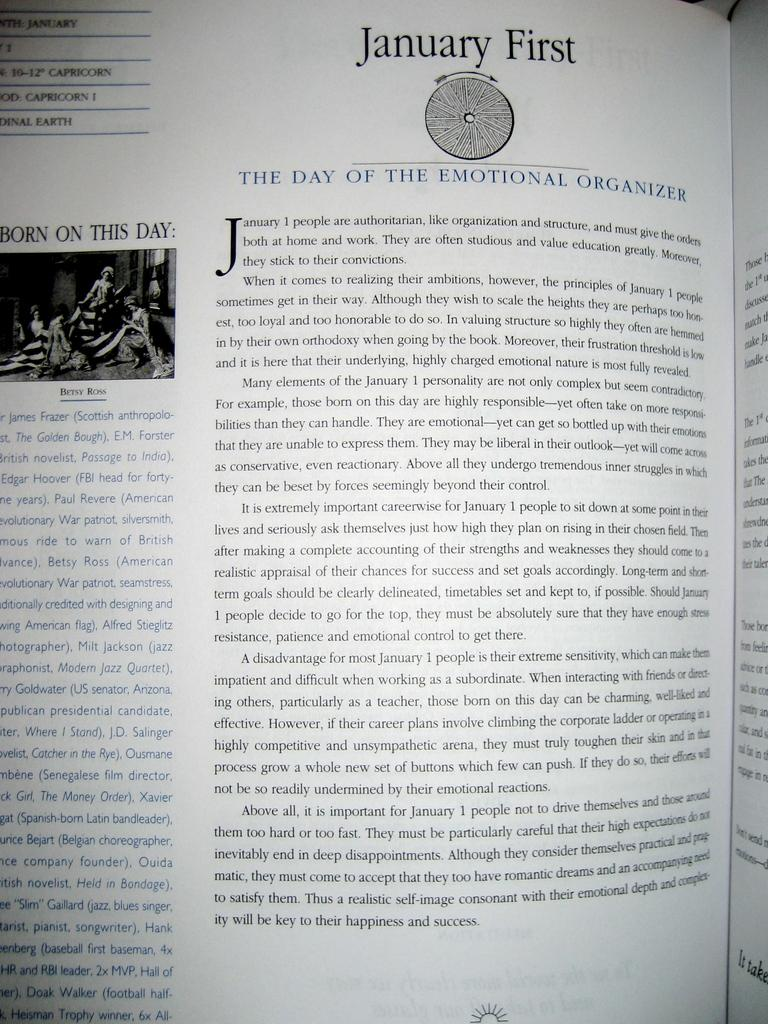<image>
Render a clear and concise summary of the photo. A book is opened to a chapter titled The Day Of The Emotional Organizer 